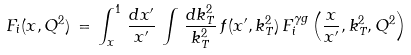Convert formula to latex. <formula><loc_0><loc_0><loc_500><loc_500>F _ { i } ( x , Q ^ { 2 } ) \, = \, \int _ { x } ^ { 1 } \, \frac { d x ^ { \prime } } { x ^ { \prime } } \, \int \, \frac { d k _ { T } ^ { 2 } } { k _ { T } ^ { 2 } } \, f ( x ^ { \prime } , k _ { T } ^ { 2 } ) \, F _ { i } ^ { \gamma g } \left ( \frac { x } { x ^ { \prime } } , k _ { T } ^ { 2 } , Q ^ { 2 } \right )</formula> 